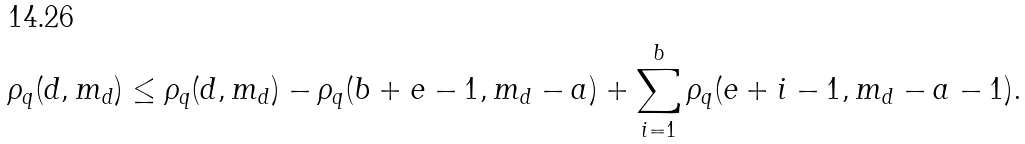Convert formula to latex. <formula><loc_0><loc_0><loc_500><loc_500>\rho _ { q } ( d , m _ { d } ) \leq \rho _ { q } ( d , m _ { d } ) - \rho _ { q } ( b + e - 1 , m _ { d } - a ) + \sum _ { i = 1 } ^ { b } \rho _ { q } ( e + i - 1 , m _ { d } - a - 1 ) .</formula> 